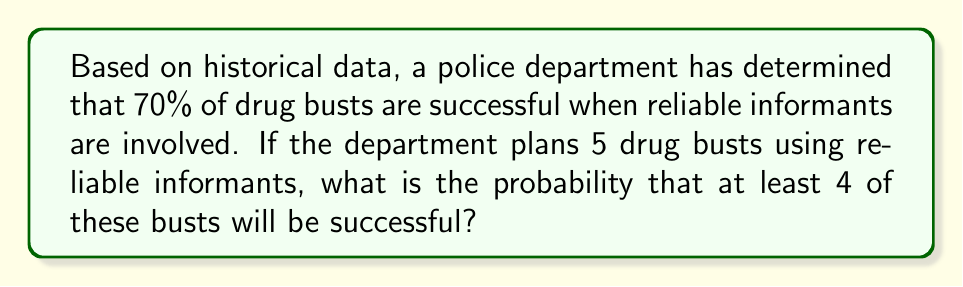Teach me how to tackle this problem. Let's approach this step-by-step using the binomial probability distribution:

1) We can model this scenario as a binomial distribution with the following parameters:
   $n = 5$ (number of trials/busts)
   $p = 0.70$ (probability of success for each bust)
   $X$ = number of successful busts

2) We need to find $P(X \geq 4)$, which is equivalent to $P(X=4) + P(X=5)$

3) The binomial probability formula is:
   $P(X = k) = \binom{n}{k} p^k (1-p)^{n-k}$

4) For $P(X = 4)$:
   $P(X = 4) = \binom{5}{4} (0.70)^4 (0.30)^1$
   $= 5 \cdot (0.2401) \cdot (0.30)$
   $= 0.3602$

5) For $P(X = 5)$:
   $P(X = 5) = \binom{5}{5} (0.70)^5 (0.30)^0$
   $= 1 \cdot (0.16807) \cdot (1)$
   $= 0.16807$

6) Therefore, $P(X \geq 4) = P(X = 4) + P(X = 5)$
   $= 0.3602 + 0.16807$
   $= 0.52827$

7) Converting to a percentage: $0.52827 \cdot 100\% = 52.827\%$
Answer: 52.827% 